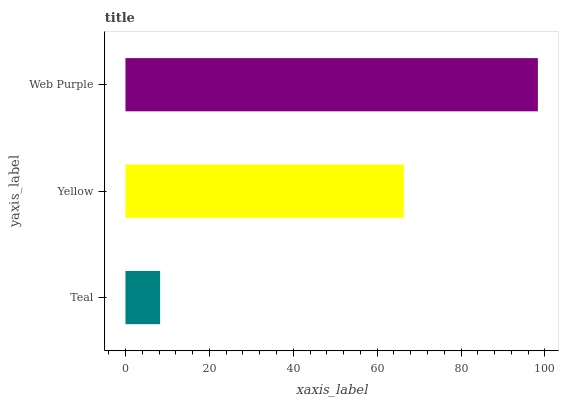Is Teal the minimum?
Answer yes or no. Yes. Is Web Purple the maximum?
Answer yes or no. Yes. Is Yellow the minimum?
Answer yes or no. No. Is Yellow the maximum?
Answer yes or no. No. Is Yellow greater than Teal?
Answer yes or no. Yes. Is Teal less than Yellow?
Answer yes or no. Yes. Is Teal greater than Yellow?
Answer yes or no. No. Is Yellow less than Teal?
Answer yes or no. No. Is Yellow the high median?
Answer yes or no. Yes. Is Yellow the low median?
Answer yes or no. Yes. Is Web Purple the high median?
Answer yes or no. No. Is Web Purple the low median?
Answer yes or no. No. 